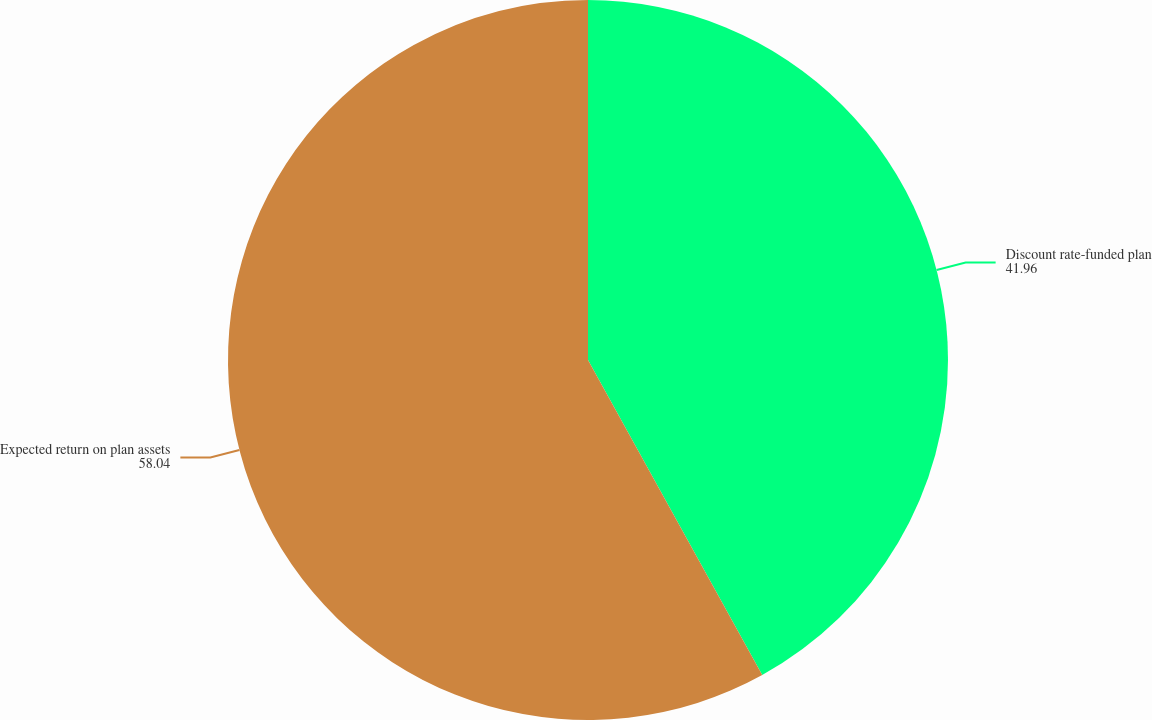Convert chart. <chart><loc_0><loc_0><loc_500><loc_500><pie_chart><fcel>Discount rate-funded plan<fcel>Expected return on plan assets<nl><fcel>41.96%<fcel>58.04%<nl></chart> 